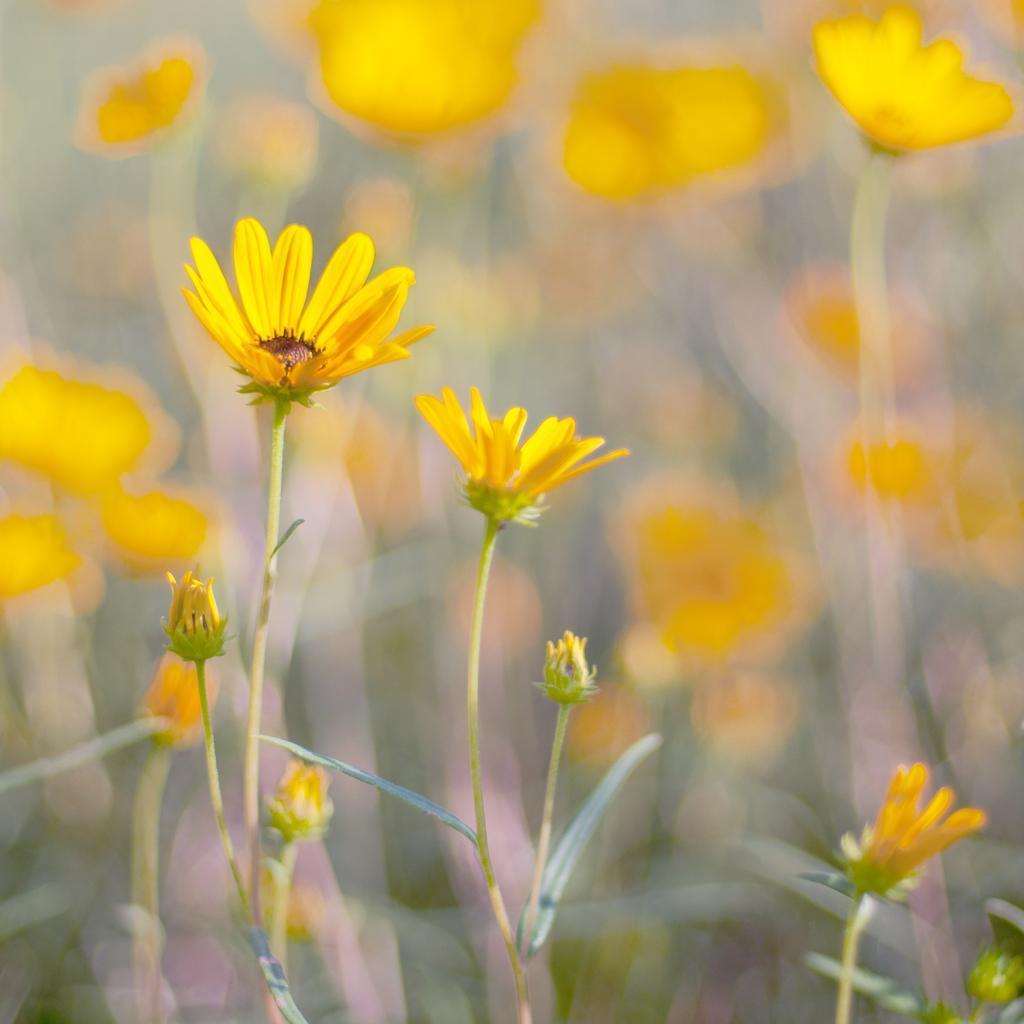Describe this image in one or two sentences. In this image we can see the flowers, flower buds and leaves. 